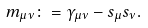Convert formula to latex. <formula><loc_0><loc_0><loc_500><loc_500>m _ { \mu \nu } \colon = \gamma _ { \mu \nu } - s _ { \mu } s _ { \nu } .</formula> 